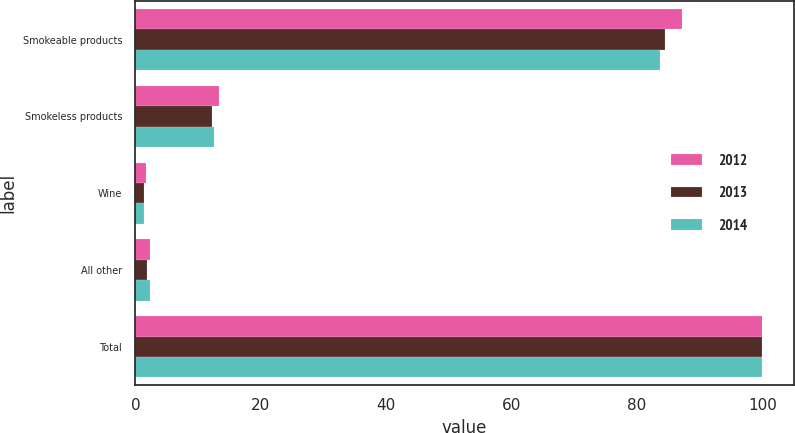Convert chart to OTSL. <chart><loc_0><loc_0><loc_500><loc_500><stacked_bar_chart><ecel><fcel>Smokeable products<fcel>Smokeless products<fcel>Wine<fcel>All other<fcel>Total<nl><fcel>2012<fcel>87.2<fcel>13.4<fcel>1.7<fcel>2.3<fcel>100<nl><fcel>2013<fcel>84.5<fcel>12.2<fcel>1.4<fcel>1.9<fcel>100<nl><fcel>2014<fcel>83.7<fcel>12.5<fcel>1.4<fcel>2.4<fcel>100<nl></chart> 